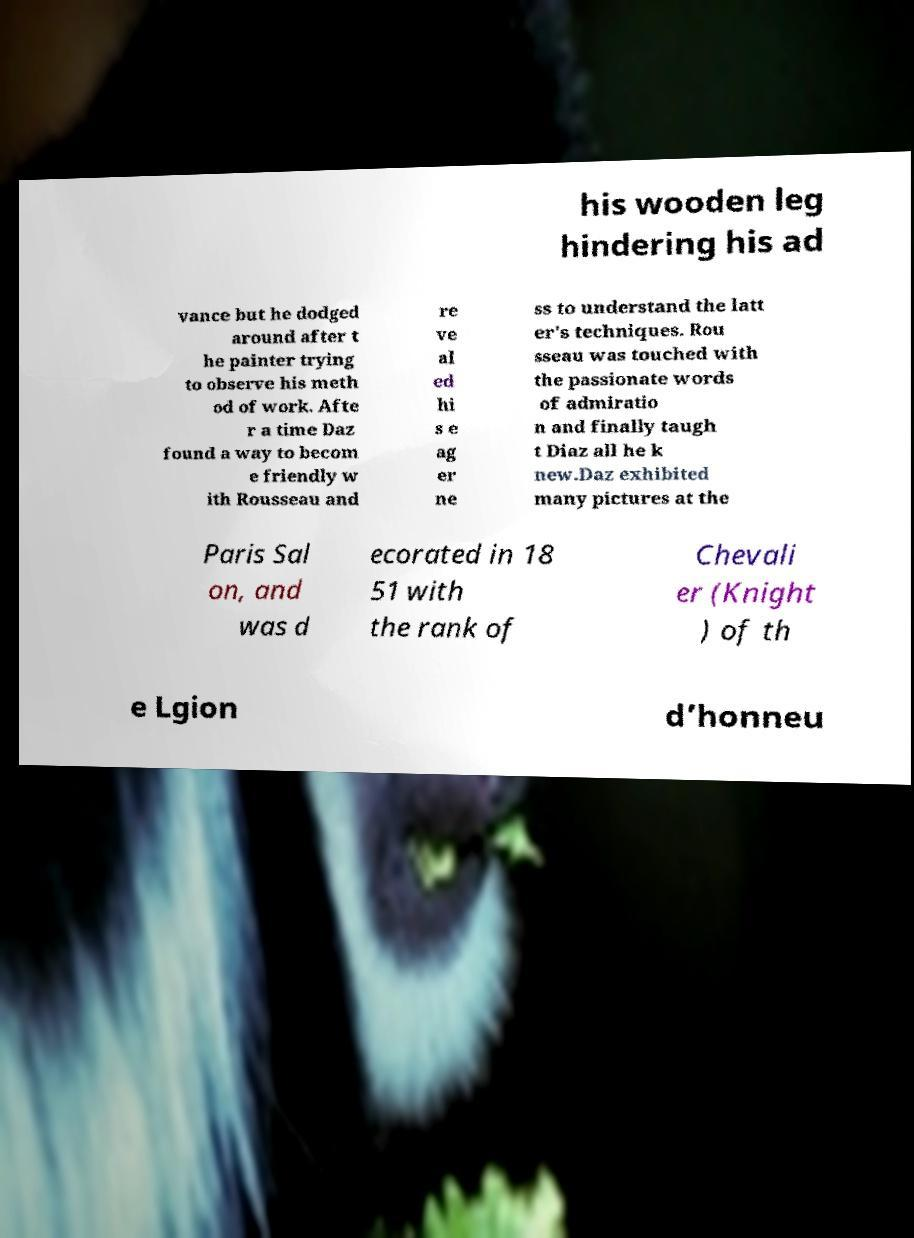Please read and relay the text visible in this image. What does it say? his wooden leg hindering his ad vance but he dodged around after t he painter trying to observe his meth od of work. Afte r a time Daz found a way to becom e friendly w ith Rousseau and re ve al ed hi s e ag er ne ss to understand the latt er's techniques. Rou sseau was touched with the passionate words of admiratio n and finally taugh t Diaz all he k new.Daz exhibited many pictures at the Paris Sal on, and was d ecorated in 18 51 with the rank of Chevali er (Knight ) of th e Lgion d’honneu 